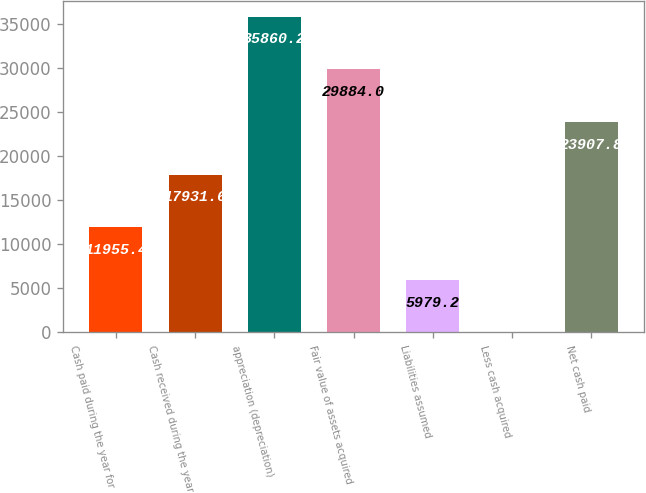Convert chart. <chart><loc_0><loc_0><loc_500><loc_500><bar_chart><fcel>Cash paid during the year for<fcel>Cash received during the year<fcel>appreciation (depreciation)<fcel>Fair value of assets acquired<fcel>Liabilities assumed<fcel>Less cash acquired<fcel>Net cash paid<nl><fcel>11955.4<fcel>17931.6<fcel>35860.2<fcel>29884<fcel>5979.2<fcel>3<fcel>23907.8<nl></chart> 